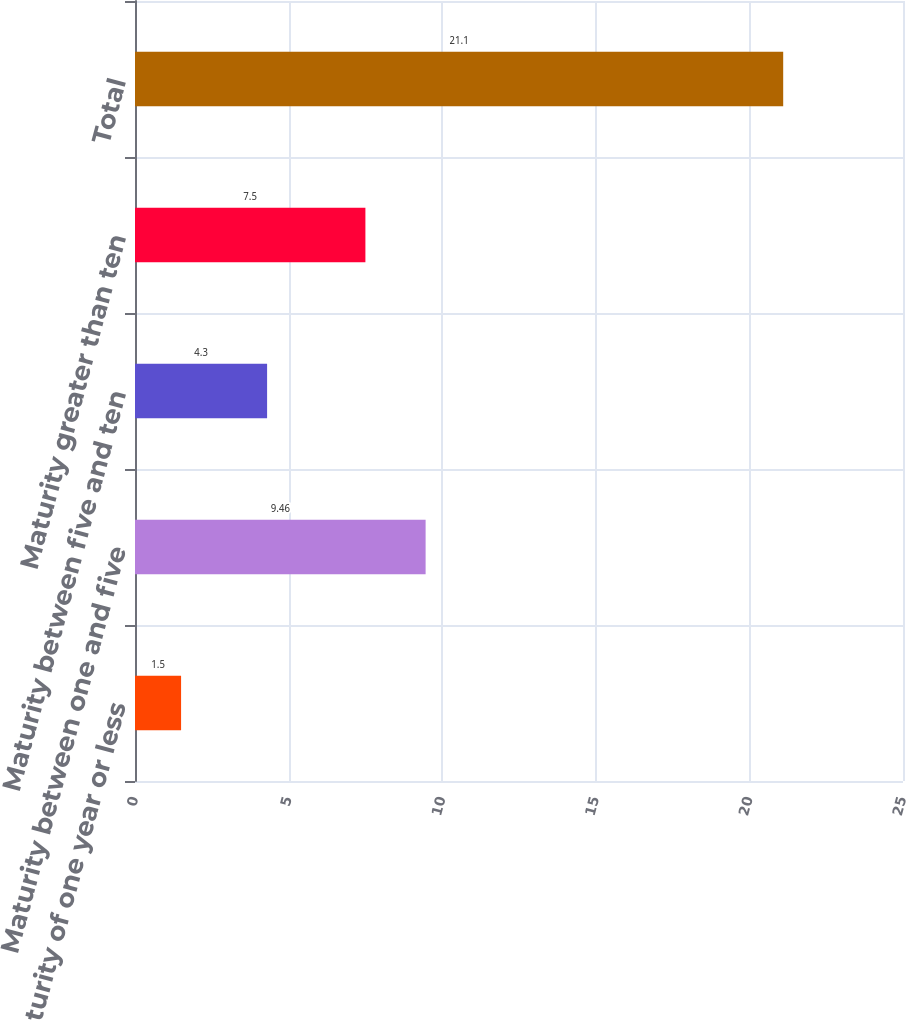<chart> <loc_0><loc_0><loc_500><loc_500><bar_chart><fcel>Maturity of one year or less<fcel>Maturity between one and five<fcel>Maturity between five and ten<fcel>Maturity greater than ten<fcel>Total<nl><fcel>1.5<fcel>9.46<fcel>4.3<fcel>7.5<fcel>21.1<nl></chart> 